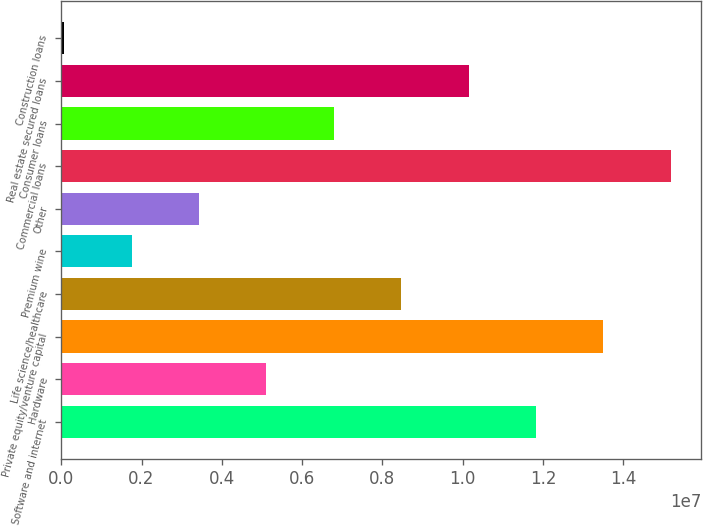<chart> <loc_0><loc_0><loc_500><loc_500><bar_chart><fcel>Software and internet<fcel>Hardware<fcel>Private equity/venture capital<fcel>Life science/healthcare<fcel>Premium wine<fcel>Other<fcel>Commercial loans<fcel>Consumer loans<fcel>Real estate secured loans<fcel>Construction loans<nl><fcel>1.18237e+07<fcel>5.11234e+06<fcel>1.35015e+07<fcel>8.468e+06<fcel>1.75669e+06<fcel>3.43452e+06<fcel>1.51793e+07<fcel>6.79017e+06<fcel>1.01458e+07<fcel>78862<nl></chart> 